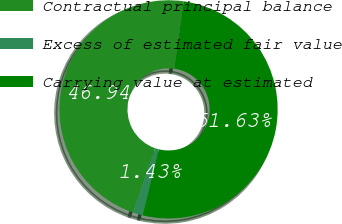<chart> <loc_0><loc_0><loc_500><loc_500><pie_chart><fcel>Contractual principal balance<fcel>Excess of estimated fair value<fcel>Carrying value at estimated<nl><fcel>46.94%<fcel>1.43%<fcel>51.63%<nl></chart> 